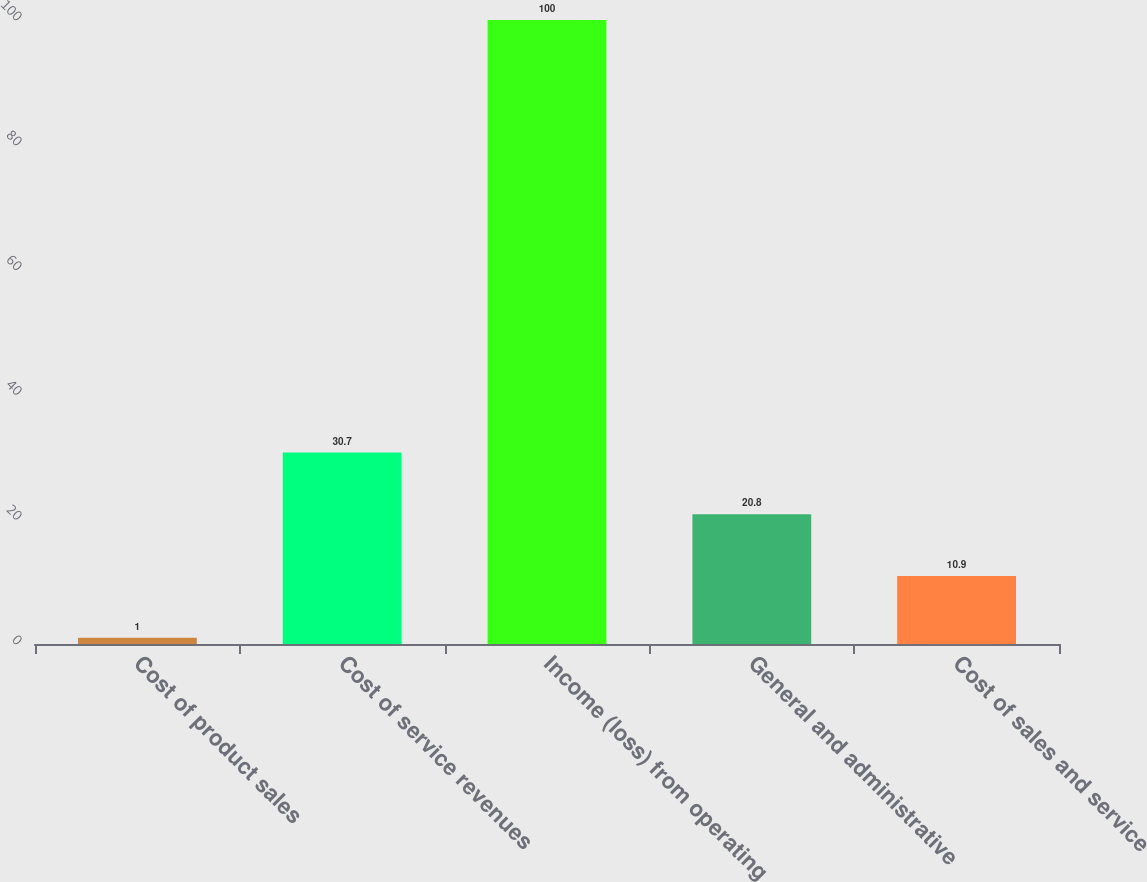Convert chart. <chart><loc_0><loc_0><loc_500><loc_500><bar_chart><fcel>Cost of product sales<fcel>Cost of service revenues<fcel>Income (loss) from operating<fcel>General and administrative<fcel>Cost of sales and service<nl><fcel>1<fcel>30.7<fcel>100<fcel>20.8<fcel>10.9<nl></chart> 